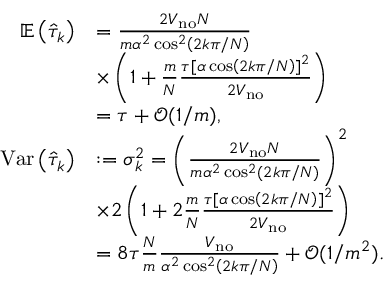<formula> <loc_0><loc_0><loc_500><loc_500>\begin{array} { r l } { \mathbb { E } \left ( \hat { \tau } _ { k } \right ) } & { = \frac { 2 V _ { n o } N } { m \alpha ^ { 2 } \cos ^ { 2 } \left ( 2 k \pi / N \right ) } } \\ & { \times \left ( 1 + \frac { m } { N } \frac { \tau [ \alpha \cos \left ( 2 k \pi / N \right ) ] ^ { 2 } } { 2 V _ { n o } } \right ) } \\ & { = \tau + \mathcal { O } ( 1 / m ) , } \\ { V a r \left ( \hat { \tau } _ { k } \right ) } & { \colon = \sigma _ { k } ^ { 2 } = \left ( \frac { 2 V _ { n o } N } { m \alpha ^ { 2 } \cos ^ { 2 } \left ( 2 k \pi / N \right ) } \right ) ^ { 2 } } \\ & { \times 2 \left ( 1 + 2 \frac { m } { N } \frac { \tau [ \alpha \cos \left ( 2 k \pi / N \right ) ] ^ { 2 } } { 2 V _ { n o } } \right ) } \\ & { = 8 \tau \frac { N } { m } \frac { V _ { n o } } { \alpha ^ { 2 } \cos ^ { 2 } \left ( 2 k \pi / N \right ) } + \mathcal { O } ( 1 / m ^ { 2 } ) . } \end{array}</formula> 